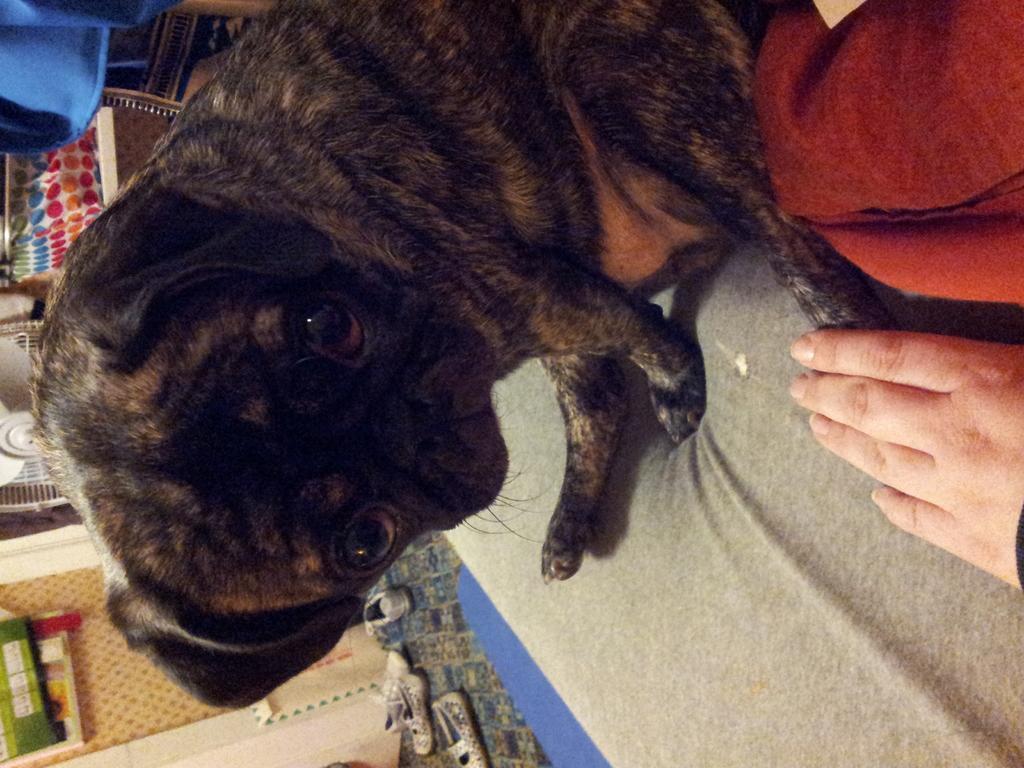Describe this image in one or two sentences. In this image we can see a dog on the surface, the hand of a person and a cloth. We can also see some shoes on the floor, posters on a wall, a table fan and a bag. 